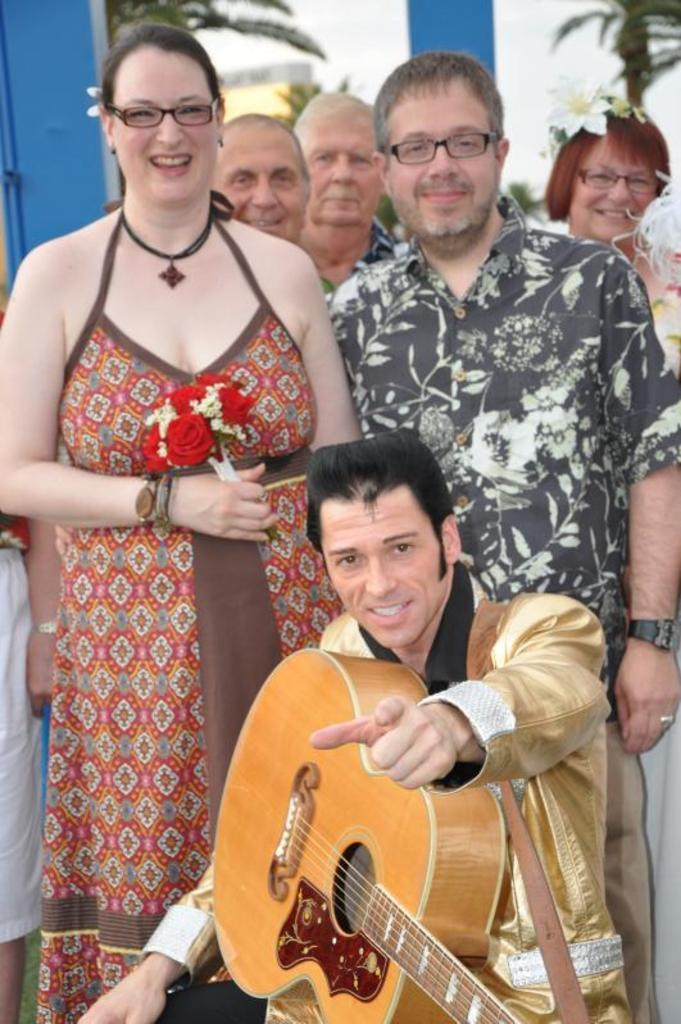How many people are in the image? There are many people standing in the image. What is the sitting person doing in the image? The sitting person is holding a guitar in his hand. Can you describe the activity of the people in the image? The people are standing, and the sitting person is holding a guitar. What type of trousers is the house wearing in the image? There is no house present in the image, and therefore no trousers can be associated with it. 